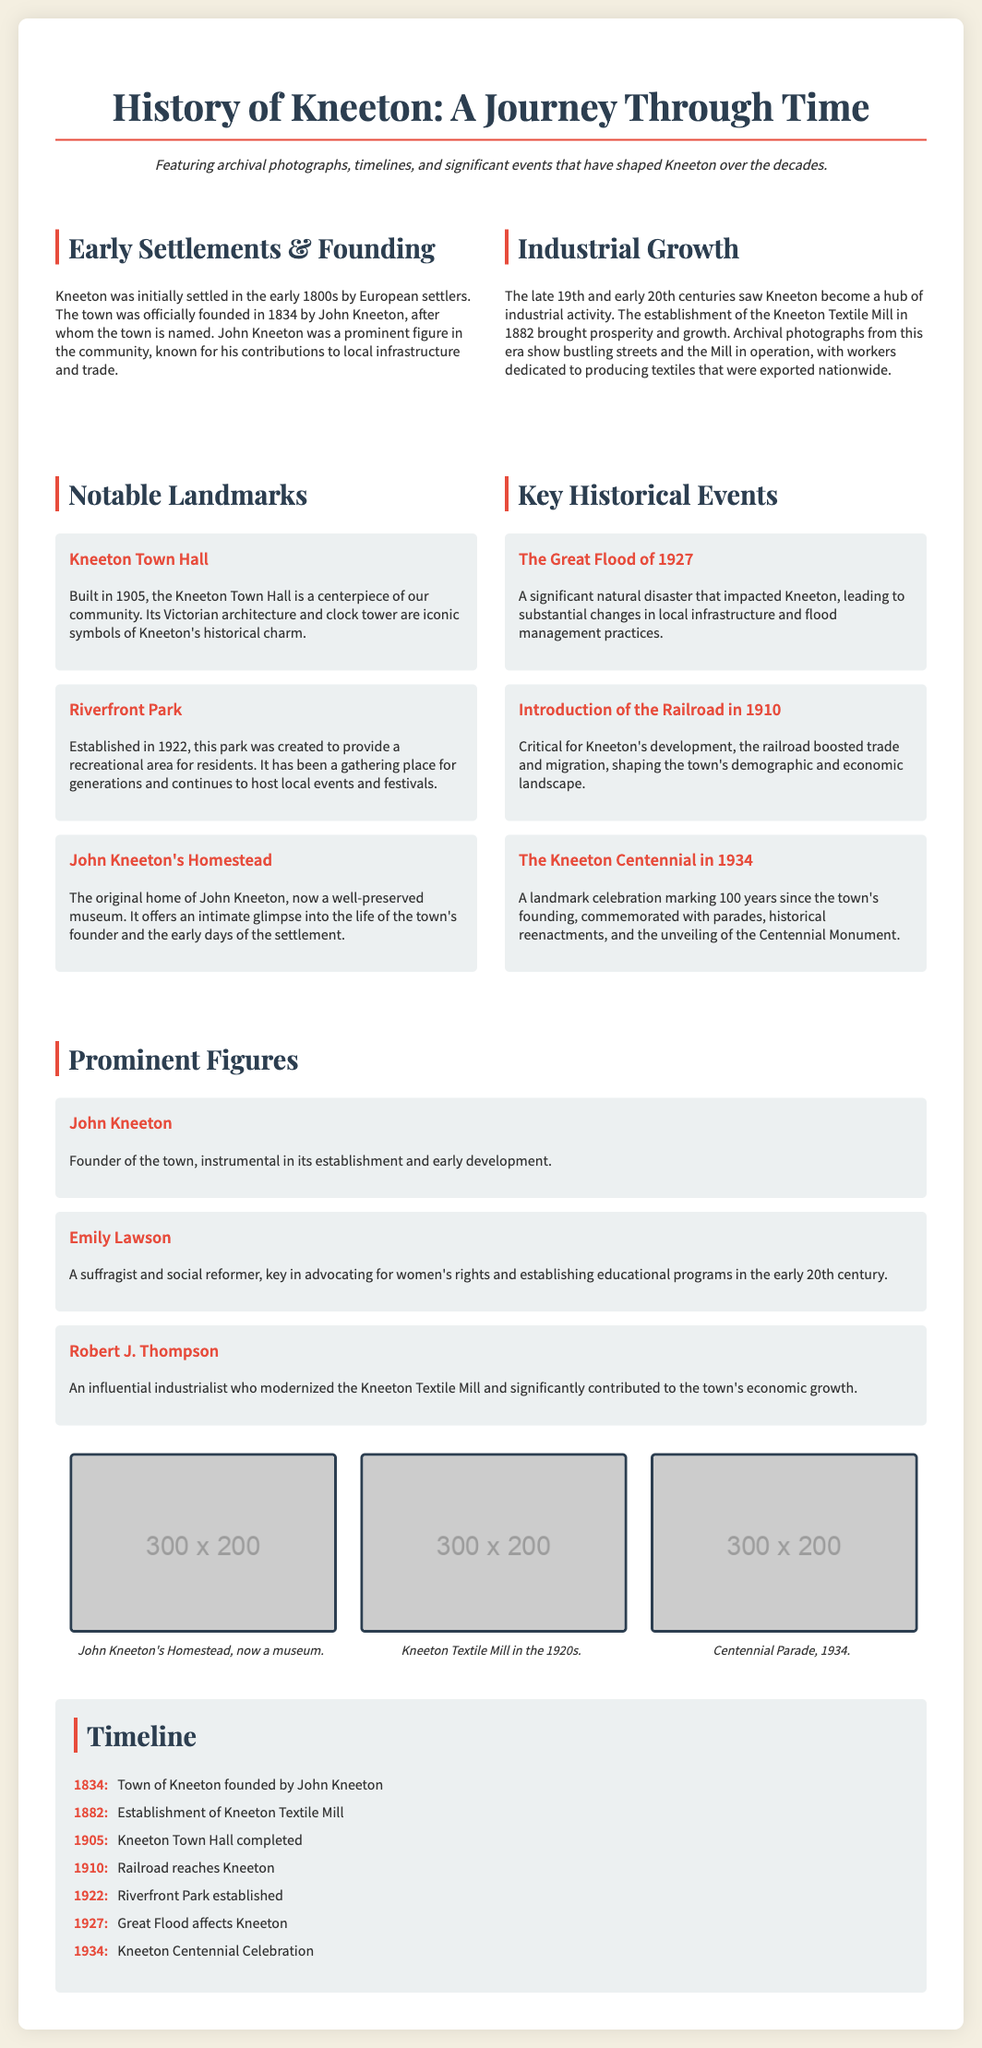What year was Kneeton officially founded? The document states that the town was officially founded in 1834 by John Kneeton.
Answer: 1834 Who was the founder of Kneeton? John Kneeton is identified as the founder of the town in the document.
Answer: John Kneeton What significant event occurred in Kneeton in 1927? The document mentions the Great Flood of 1927 as a significant natural disaster that impacted Kneeton.
Answer: Great Flood What landmark was completed in 1905? The document specifically mentions the Kneeton Town Hall was completed in 1905.
Answer: Kneeton Town Hall Who was a key figure in advocating for women's rights in Kneeton? Emily Lawson is highlighted as a suffragist and social reformer in the document.
Answer: Emily Lawson What economic activity became prominent in Kneeton in the late 19th century? Establishment of the Kneeton Textile Mill in 1882 marked the industrial growth of Kneeton.
Answer: Industrial activity What year did the Riverfront Park establish? The document states that Riverfront Park was established in 1922.
Answer: 1922 What celebration took place in 1934 in Kneeton? The document notes the Kneeton Centennial as a landmark celebration in 1934 marking 100 years since the town's founding.
Answer: Kneeton Centennial Which architectural style is associated with Kneeton Town Hall? The document describes the architecture of Kneeton Town Hall as Victorian.
Answer: Victorian 